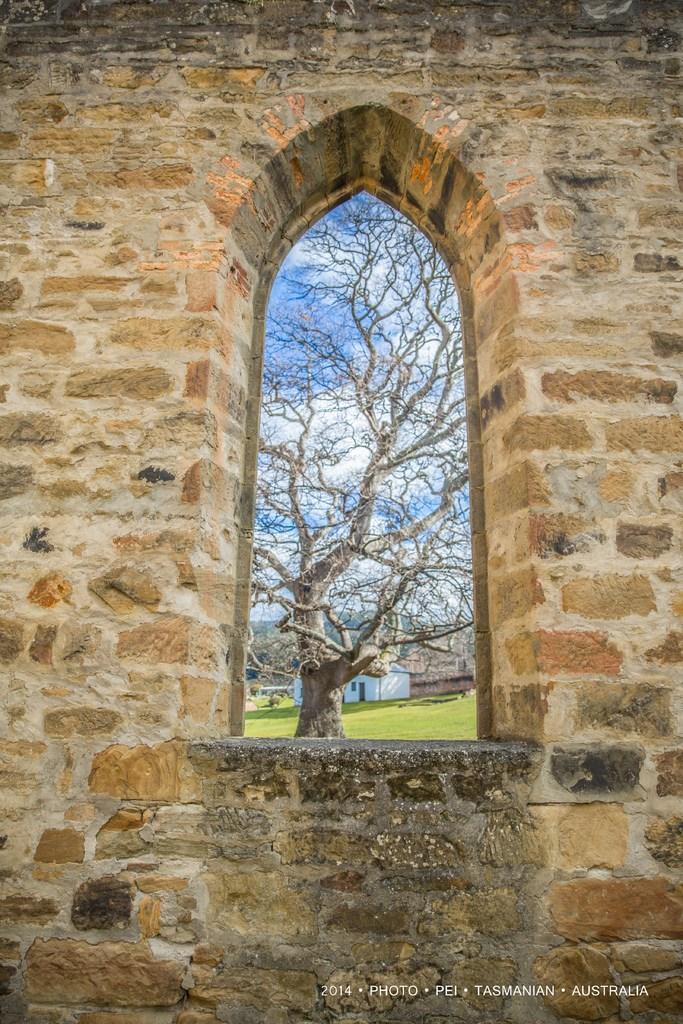Please provide a concise description of this image. This image is taken outdoors. In this image there is a wall with a window. In the middle of the image there is a house and there is a ground with grass and a tree on it. There is a sky with clouds. 